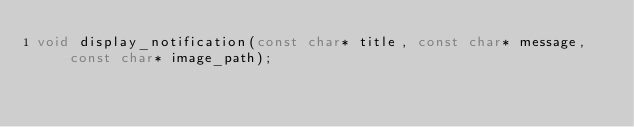Convert code to text. <code><loc_0><loc_0><loc_500><loc_500><_C_>void display_notification(const char* title, const char* message, const char* image_path);</code> 